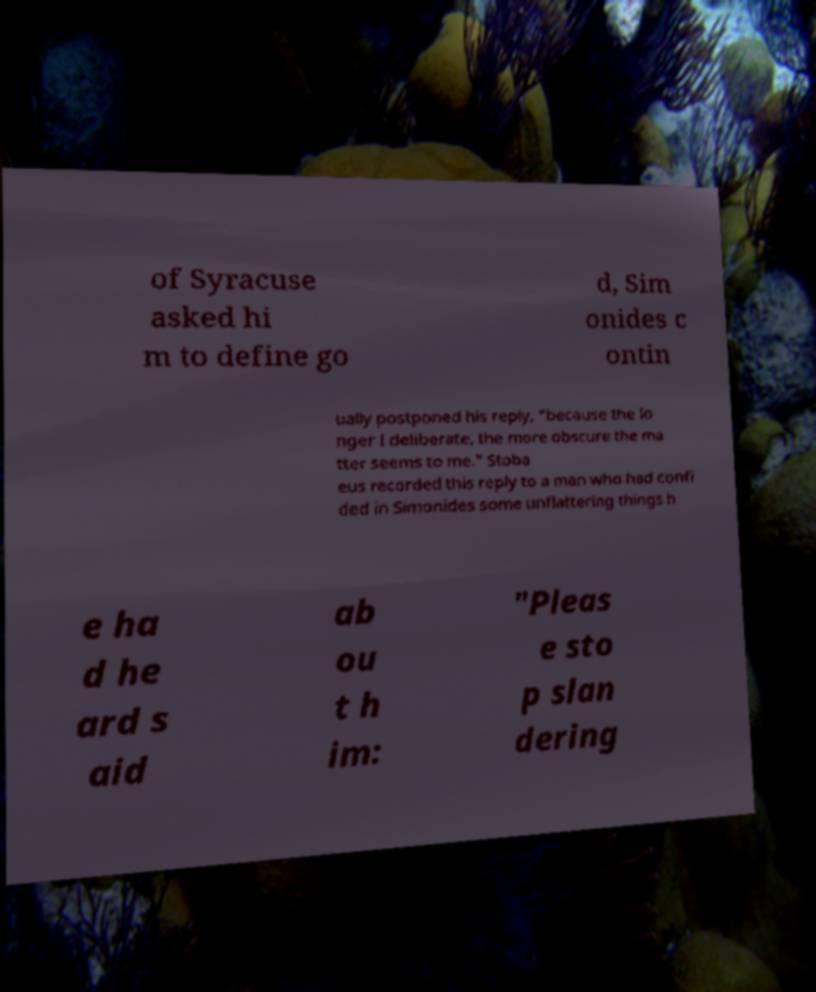Could you extract and type out the text from this image? of Syracuse asked hi m to define go d, Sim onides c ontin ually postponed his reply, "because the lo nger I deliberate, the more obscure the ma tter seems to me." Stoba eus recorded this reply to a man who had confi ded in Simonides some unflattering things h e ha d he ard s aid ab ou t h im: "Pleas e sto p slan dering 